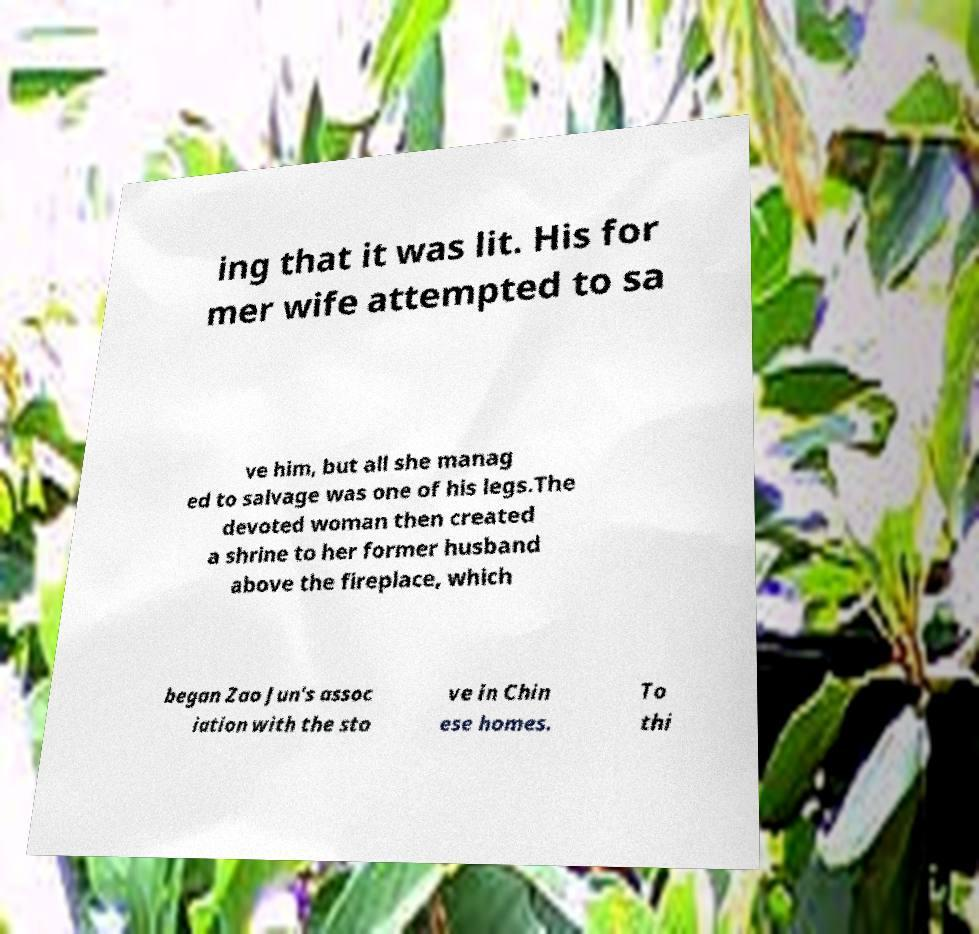What messages or text are displayed in this image? I need them in a readable, typed format. ing that it was lit. His for mer wife attempted to sa ve him, but all she manag ed to salvage was one of his legs.The devoted woman then created a shrine to her former husband above the fireplace, which began Zao Jun's assoc iation with the sto ve in Chin ese homes. To thi 